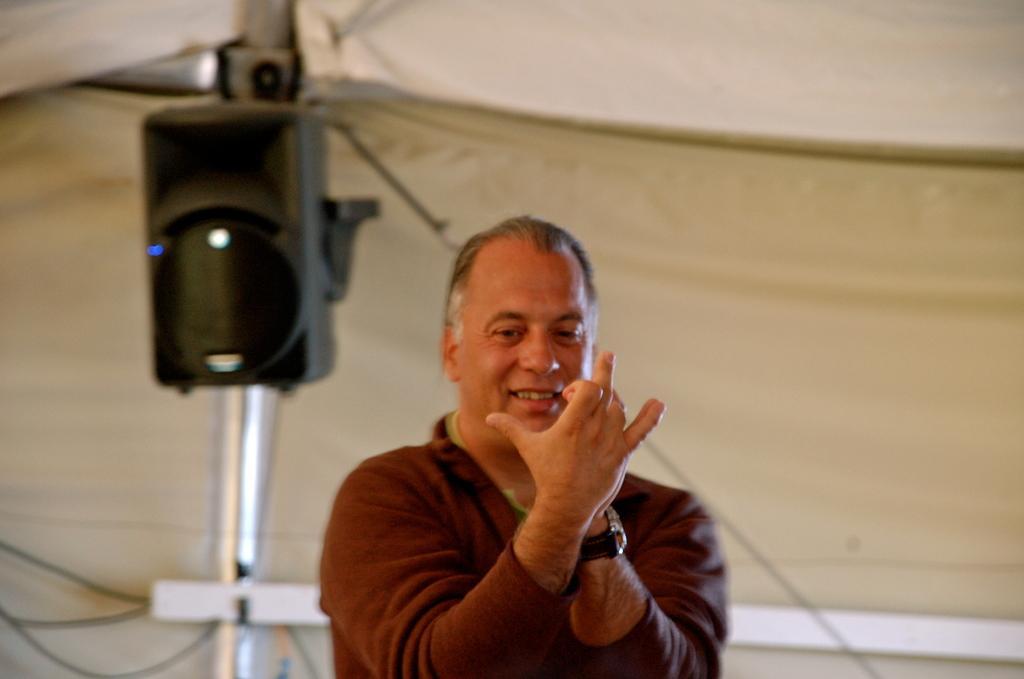In one or two sentences, can you explain what this image depicts? In the picture I can see a man is standing. The man is wearing a watch in the hand. In the background I can see a sound speaker attached to the pole and some other objects. The background of the image is blurred. 